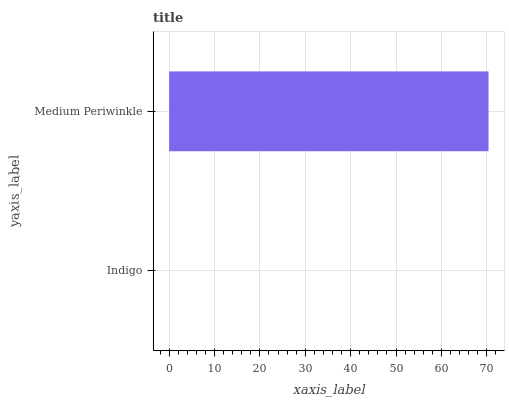Is Indigo the minimum?
Answer yes or no. Yes. Is Medium Periwinkle the maximum?
Answer yes or no. Yes. Is Medium Periwinkle the minimum?
Answer yes or no. No. Is Medium Periwinkle greater than Indigo?
Answer yes or no. Yes. Is Indigo less than Medium Periwinkle?
Answer yes or no. Yes. Is Indigo greater than Medium Periwinkle?
Answer yes or no. No. Is Medium Periwinkle less than Indigo?
Answer yes or no. No. Is Medium Periwinkle the high median?
Answer yes or no. Yes. Is Indigo the low median?
Answer yes or no. Yes. Is Indigo the high median?
Answer yes or no. No. Is Medium Periwinkle the low median?
Answer yes or no. No. 